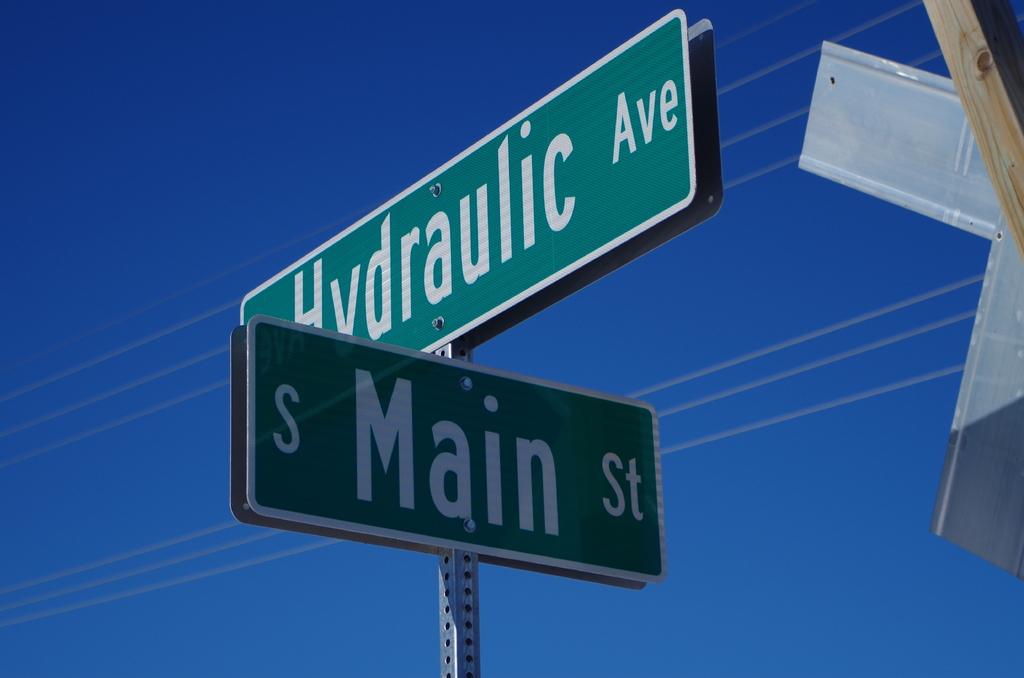What is the name of the street?
Ensure brevity in your answer.  Main. 